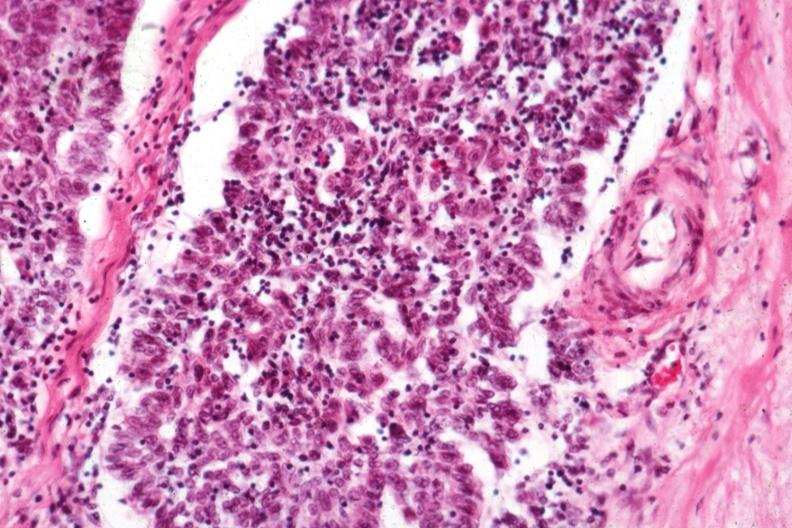does this image show predominant epithelial component?
Answer the question using a single word or phrase. Yes 